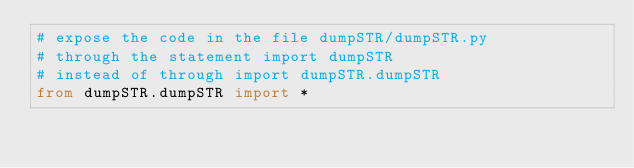Convert code to text. <code><loc_0><loc_0><loc_500><loc_500><_Python_># expose the code in the file dumpSTR/dumpSTR.py
# through the statement import dumpSTR
# instead of through import dumpSTR.dumpSTR
from dumpSTR.dumpSTR import *
</code> 